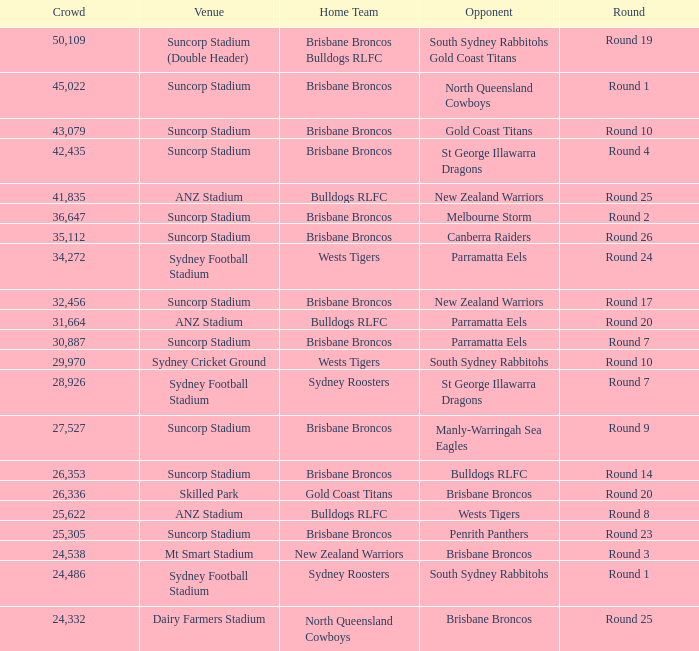What was the attendance at Round 9? 1.0. 